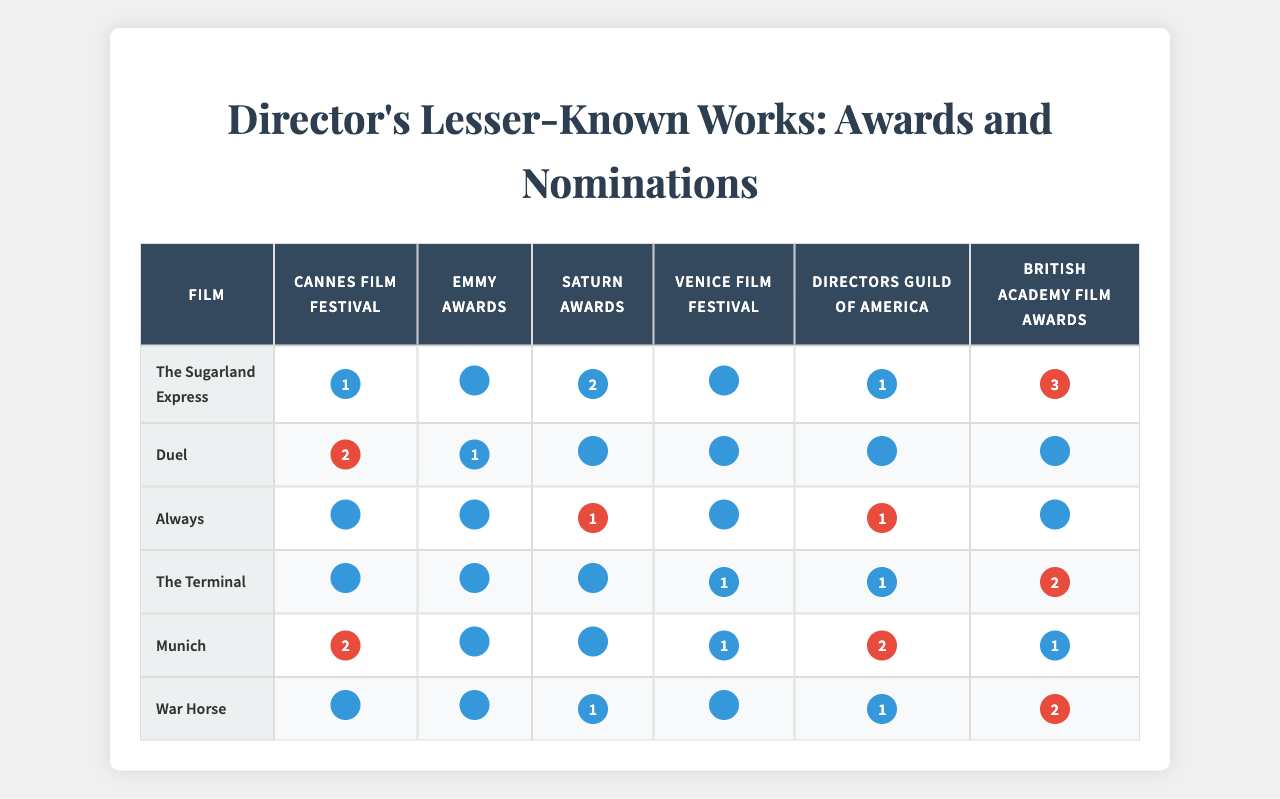What is the total count of awards received by "The Sugarland Express"? The table shows that "The Sugarland Express" won 1 award at the Cannes Film Festival, 0 at the Emmy Awards, 2 at the Saturn Awards, 0 at the Venice Film Festival, 1 at the Directors Guild of America, and 3 at the British Academy Film Awards. Summing these values gives 1 + 0 + 2 + 0 + 1 + 3 = 7.
Answer: 7 Which film received the highest number of Saturn Awards? Looking at the column for the Saturn Awards in the table, "The Sugarland Express" has 2 Saturn Awards, while "Duel" has 0, "Always" has 1, "The Terminal" has 0, "Munich" has 0, and "War Horse" has 1. The highest count is 2 for "The Sugarland Express".
Answer: The Sugarland Express Did "Munich" receive more awards at the Directors Guild of America than "War Horse"? According to the table, "Munich" received 0 awards at the Directors Guild of America, while "War Horse" received 1 award. Therefore, Munich did not receive more awards than War Horse.
Answer: No What is the total number of awards won by "War Horse"? The table indicates that "War Horse" won 0 awards at the Cannes Film Festival, 0 at the Emmy Awards, 1 at the Saturn Awards, 0 at the Venice Film Festival, 1 at the Directors Guild of America, and 2 at the British Academy Film Awards. Adding these awards results in 0 + 0 + 1 + 0 + 1 + 2 = 4.
Answer: 4 Which film has the most awards at the Venice Film Festival and how many? Reviewing the Venice Film Festival awards, "The Terminal" won 1, while "The Sugarland Express", "Duel", "Always", "Munich", and "War Horse" all received 0. The highest number of awards is 1, won by "The Terminal."
Answer: The Terminal; 1 What is the average number of awards received by the films listed in the table? To find the average, first sum the awards: (7 + 3 + 2 + 3 + 5 + 4 = 24). There are 6 films listed, so the average is 24/6 = 4.
Answer: 4 Which film received the highest count of total awards across all categories? By summing the awards for each film, the total counts are: The Sugarland Express: 7, Duel: 3, Always: 2, The Terminal: 3, Munich: 5, War Horse: 4. The highest total is 7 for "The Sugarland Express."
Answer: The Sugarland Express Is it true that "Always" won awards in more than two categories? "Always" won 0 at Cannes, 0 at the Emmy Awards, 1 at the Saturn Awards, 0 at Venice, 1 at the Directors Guild, and 0 at the BAFTA. Therefore, it won in only 2 categories, which means the statement is false.
Answer: No 